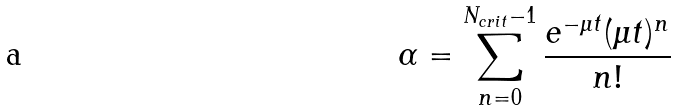Convert formula to latex. <formula><loc_0><loc_0><loc_500><loc_500>\alpha = \sum _ { n = 0 } ^ { N _ { c r i t } - 1 } \frac { e ^ { - \mu t } ( \mu t ) ^ { n } } { n ! }</formula> 